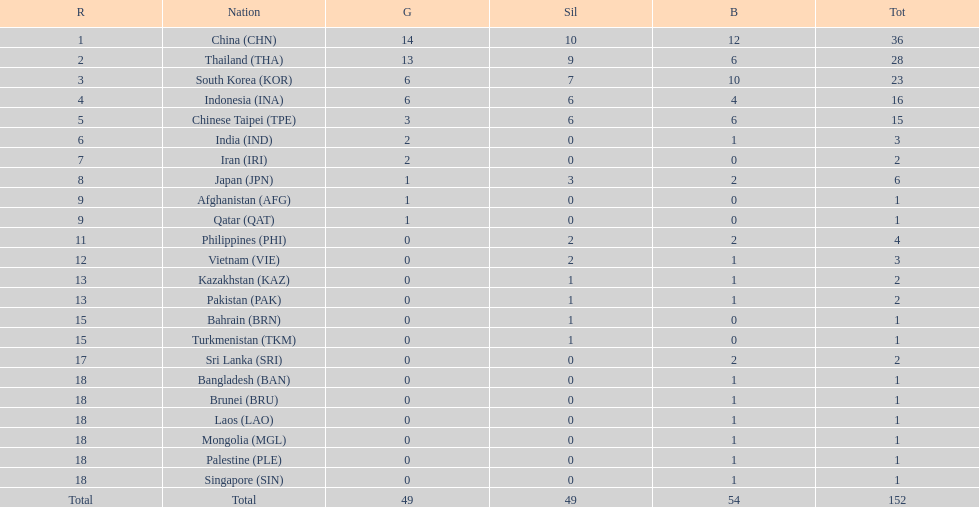What was the number of medals earned by indonesia (ina) ? 16. 